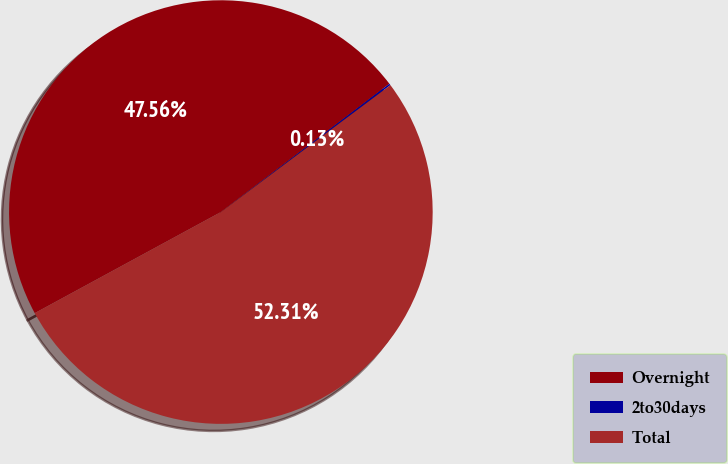Convert chart. <chart><loc_0><loc_0><loc_500><loc_500><pie_chart><fcel>Overnight<fcel>2to30days<fcel>Total<nl><fcel>47.56%<fcel>0.13%<fcel>52.31%<nl></chart> 